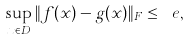Convert formula to latex. <formula><loc_0><loc_0><loc_500><loc_500>\sup _ { x \in D } \| f ( x ) - g ( x ) \| _ { F } \leq \ e ,</formula> 